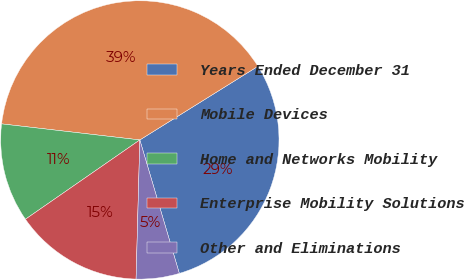Convert chart to OTSL. <chart><loc_0><loc_0><loc_500><loc_500><pie_chart><fcel>Years Ended December 31<fcel>Mobile Devices<fcel>Home and Networks Mobility<fcel>Enterprise Mobility Solutions<fcel>Other and Eliminations<nl><fcel>29.29%<fcel>39.28%<fcel>11.49%<fcel>14.92%<fcel>5.01%<nl></chart> 